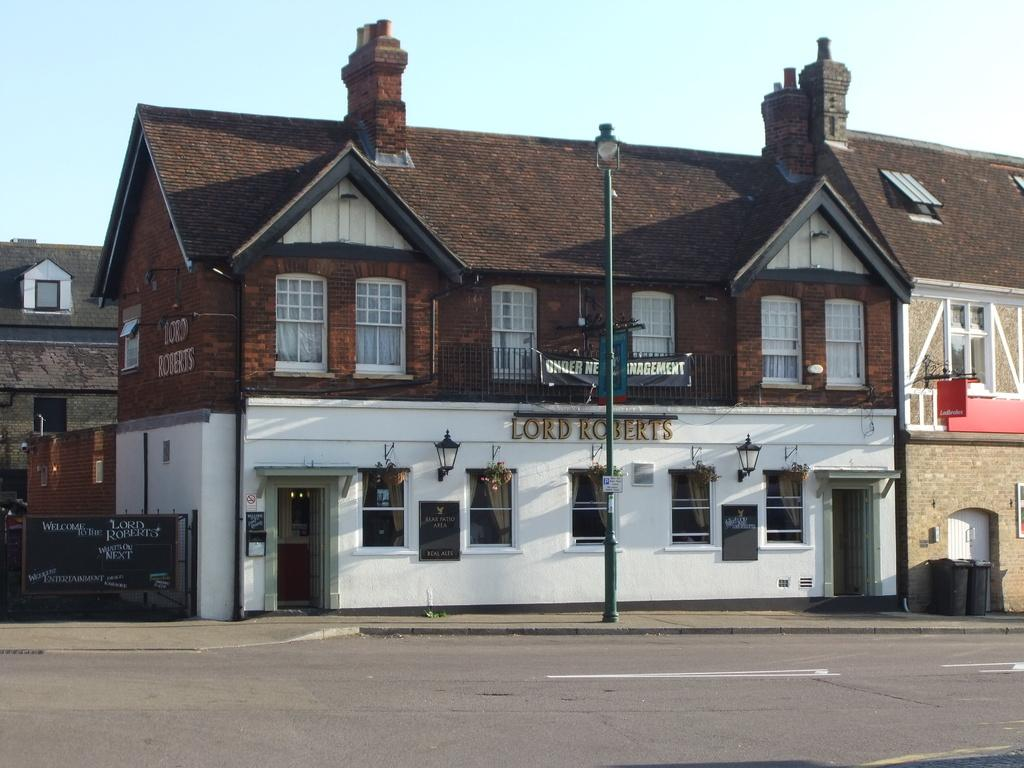What objects can be seen in the image? There are boards, lights, dustbins, iron grilles, and a banner in the image. What type of structures are visible in the image? There are buildings in the image. What can be seen in the background of the image? The sky is visible in the background of the image. What type of turkey can be seen swimming in the image? There is no turkey or any body of water present in the image. What direction is the ship blowing in the image? There is no ship or blowing wind present in the image. 